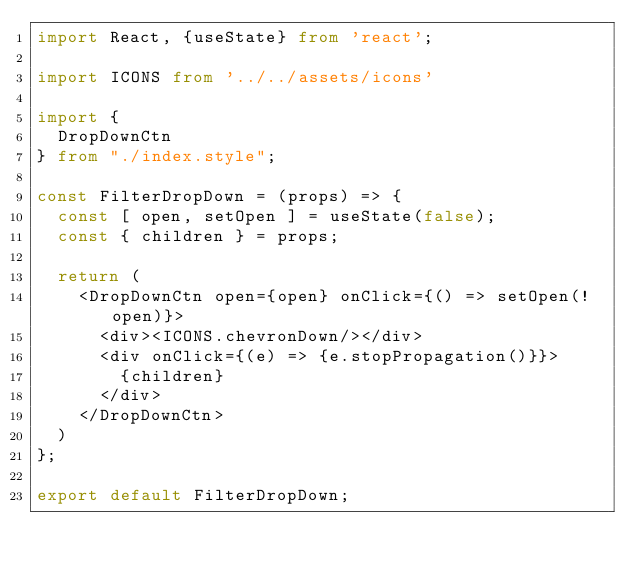<code> <loc_0><loc_0><loc_500><loc_500><_TypeScript_>import React, {useState} from 'react';

import ICONS from '../../assets/icons'

import {
  DropDownCtn
} from "./index.style";

const FilterDropDown = (props) => {
  const [ open, setOpen ] = useState(false);
  const { children } = props;

  return (
    <DropDownCtn open={open} onClick={() => setOpen(!open)}>
      <div><ICONS.chevronDown/></div>
      <div onClick={(e) => {e.stopPropagation()}}>
        {children}
      </div>
    </DropDownCtn>
  )
};

export default FilterDropDown;</code> 